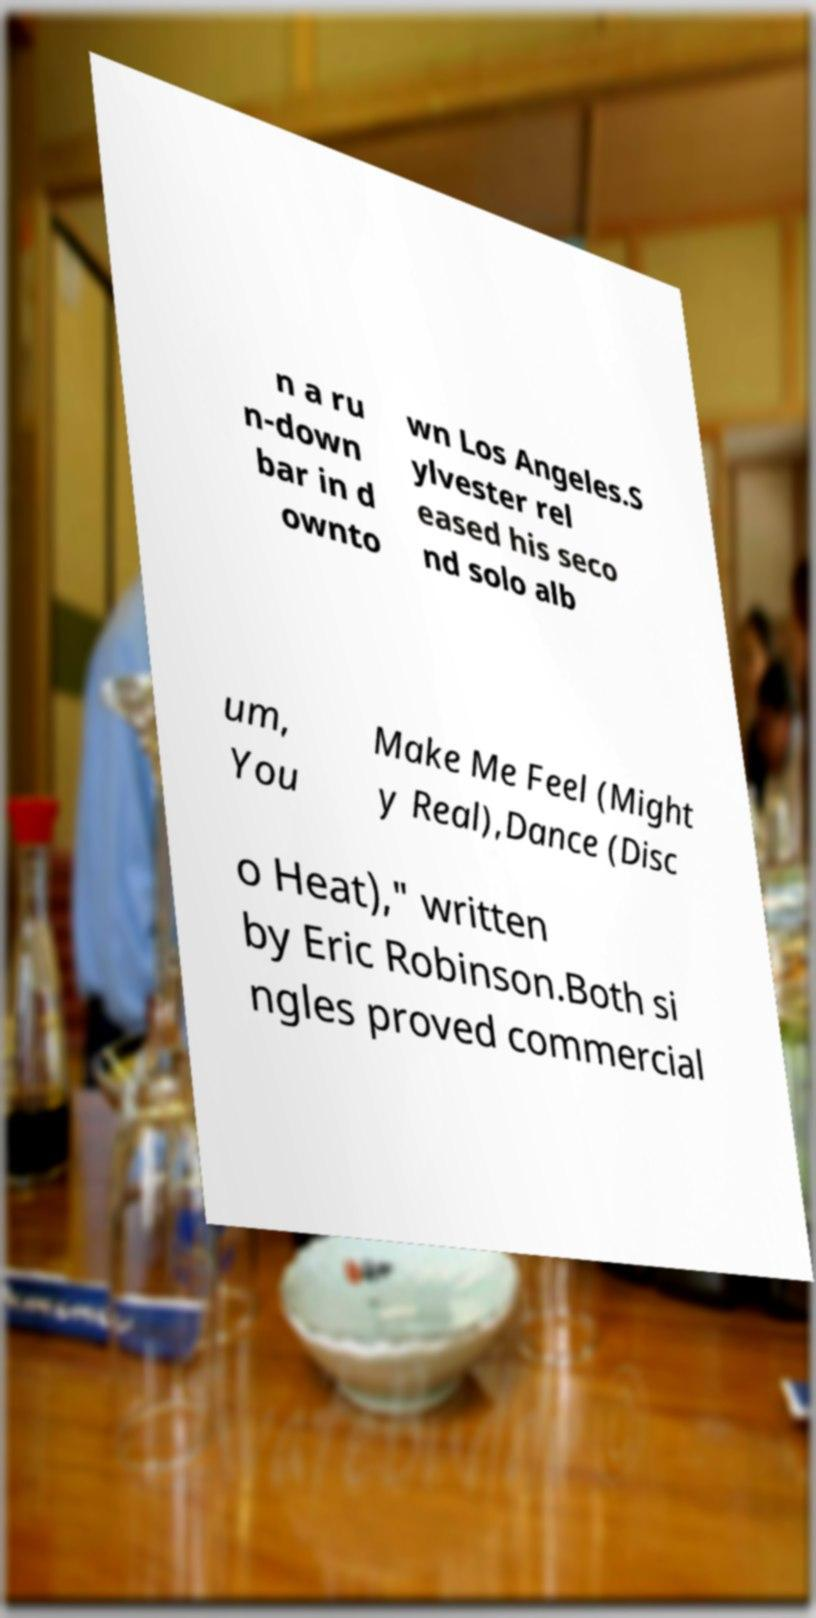Can you accurately transcribe the text from the provided image for me? n a ru n-down bar in d ownto wn Los Angeles.S ylvester rel eased his seco nd solo alb um, You Make Me Feel (Might y Real),Dance (Disc o Heat)," written by Eric Robinson.Both si ngles proved commercial 